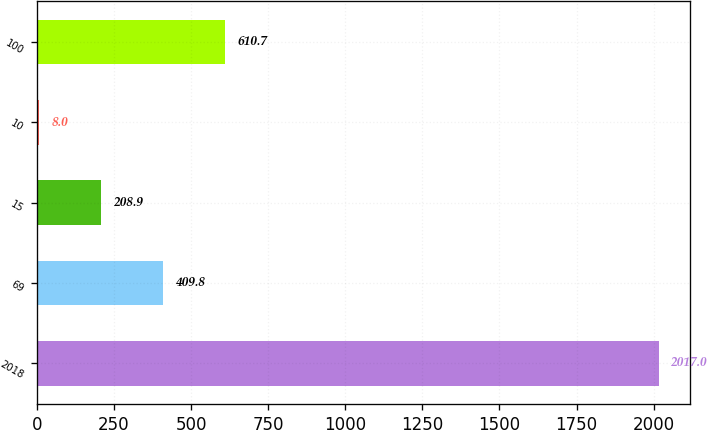Convert chart. <chart><loc_0><loc_0><loc_500><loc_500><bar_chart><fcel>2018<fcel>69<fcel>15<fcel>10<fcel>100<nl><fcel>2017<fcel>409.8<fcel>208.9<fcel>8<fcel>610.7<nl></chart> 